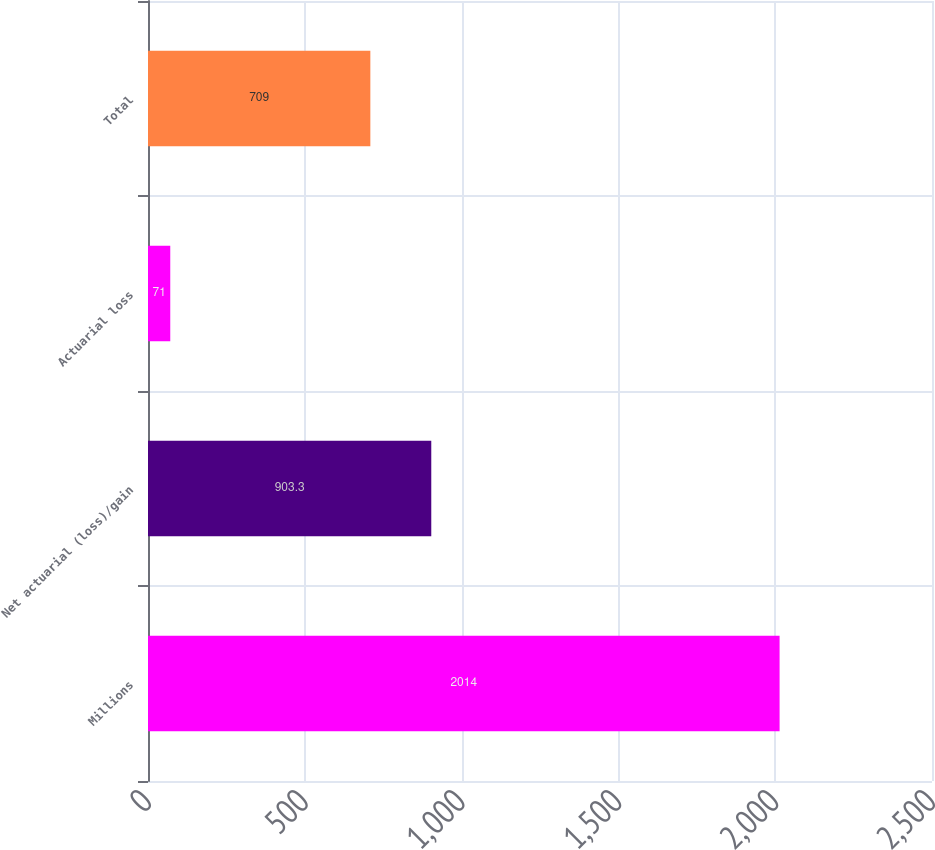Convert chart to OTSL. <chart><loc_0><loc_0><loc_500><loc_500><bar_chart><fcel>Millions<fcel>Net actuarial (loss)/gain<fcel>Actuarial loss<fcel>Total<nl><fcel>2014<fcel>903.3<fcel>71<fcel>709<nl></chart> 